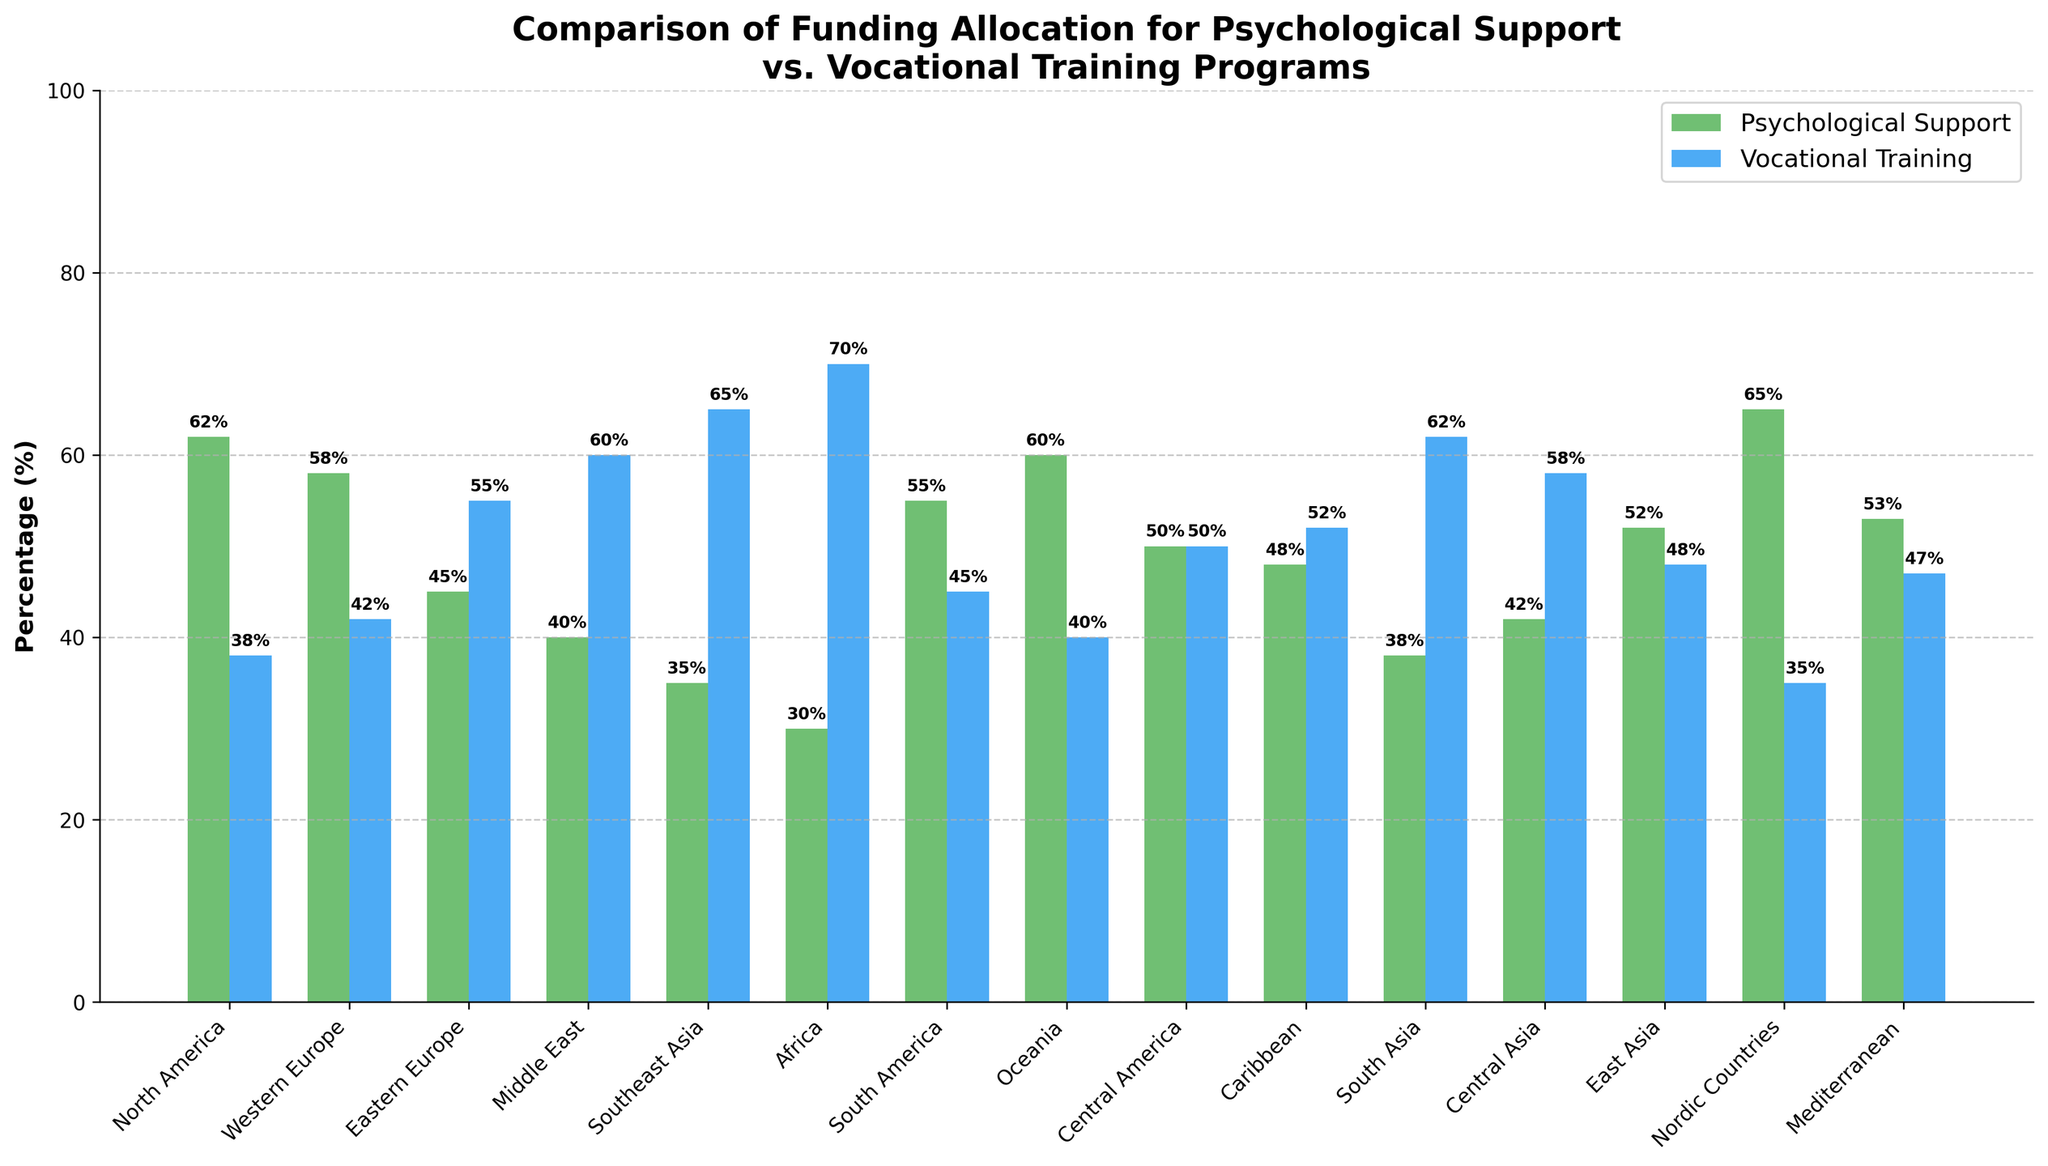Which region has the highest funding allocation for psychological support? By looking at the bar with the greatest height in the "Psychological Support" color (green), we can see that the Nordic Countries receive the highest funding at 65%.
Answer: Nordic Countries Which region allocates an equal percentage to both psychological support and vocational training? By observing the bars, we can see that Central America has equal heights for both programs, each at 50%.
Answer: Central America In which two regions does vocational training receive more funding than psychological support by at least 10%? We compare the heights of the two bars in each region and find that in Southeast Asia and Africa, the vocational training allocation is at least 10% greater than the psychological support allocation. Specifically, Southeast Asia has 35% for psychological support and 65% for vocational training, and Africa has 30% for psychological support and 70% for vocational training.
Answer: Southeast Asia, Africa What is the difference between the highest and lowest funding percentages for psychological support? The highest funding percentage for psychological support is in the Nordic Countries at 65%, and the lowest is in Africa at 30%. The difference is 65% - 30% = 35%.
Answer: 35% Which three regions have the most balanced funding distribution between psychological support and vocational training? We look for regions where the heights of the two bars are closest. Central America (50%-50%), Caribbean (48%-52%), and Eastern Europe (45%-55%) show the most balanced distributions.
Answer: Central America, Caribbean, Eastern Europe How much more funding does North America allocate to psychological support compared to vocational training? In North America, 62% is allocated to psychological support and 38% to vocational training. The difference is 62% - 38% = 24%.
Answer: 24% On average, what percentage of funding is allocated to psychological support across all regions? Summing up all the psychological support percentages (62 + 58 + 45 + 40 + 35 + 30 + 55 + 60 + 50 + 48 + 38 + 42 + 52 + 65 + 53) results in 733. The number of regions is 15. Thus, the average percentage is 733 / 15 = 48.867% or approximately 48.87%.
Answer: 48.87% Which regions allocate more than 50% of their funding to vocational training? We note the regions where the heights of the "Vocational Training" bars are more than halfway up. These are Eastern Europe (55%), Middle East (60%), Southeast Asia (65%), Africa (70%), South Asia (62%), and Central Asia (58%).
Answer: Eastern Europe, Middle East, Southeast Asia, Africa, South Asia, Central Asia 